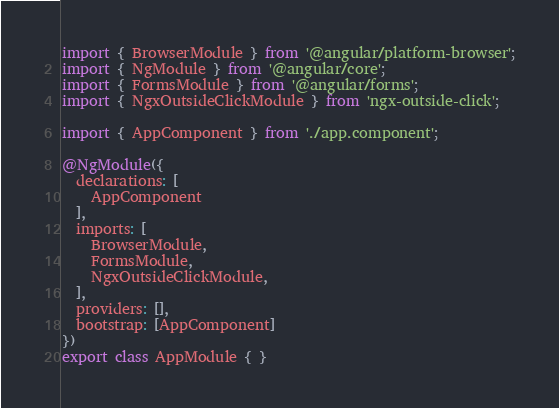Convert code to text. <code><loc_0><loc_0><loc_500><loc_500><_TypeScript_>import { BrowserModule } from '@angular/platform-browser';
import { NgModule } from '@angular/core';
import { FormsModule } from '@angular/forms';
import { NgxOutsideClickModule } from 'ngx-outside-click';

import { AppComponent } from './app.component';

@NgModule({
  declarations: [
    AppComponent
  ],
  imports: [
    BrowserModule,
    FormsModule,
    NgxOutsideClickModule,
  ],
  providers: [],
  bootstrap: [AppComponent]
})
export class AppModule { }
</code> 